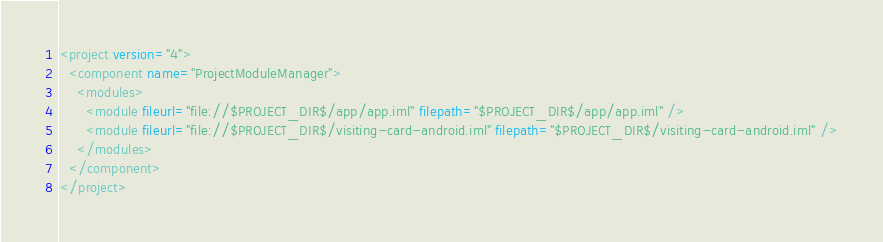Convert code to text. <code><loc_0><loc_0><loc_500><loc_500><_XML_><project version="4">
  <component name="ProjectModuleManager">
    <modules>
      <module fileurl="file://$PROJECT_DIR$/app/app.iml" filepath="$PROJECT_DIR$/app/app.iml" />
      <module fileurl="file://$PROJECT_DIR$/visiting-card-android.iml" filepath="$PROJECT_DIR$/visiting-card-android.iml" />
    </modules>
  </component>
</project></code> 